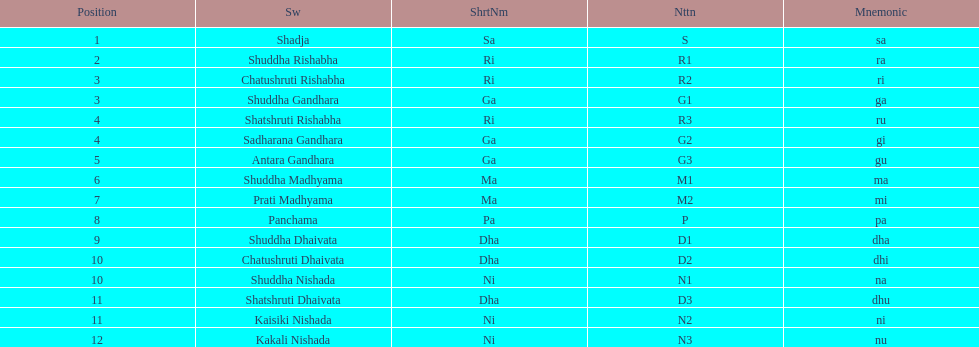List each pair of swaras that share the same position. Chatushruti Rishabha, Shuddha Gandhara, Shatshruti Rishabha, Sadharana Gandhara, Chatushruti Dhaivata, Shuddha Nishada, Shatshruti Dhaivata, Kaisiki Nishada. 